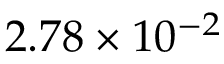<formula> <loc_0><loc_0><loc_500><loc_500>2 . 7 8 \times 1 0 ^ { - 2 }</formula> 